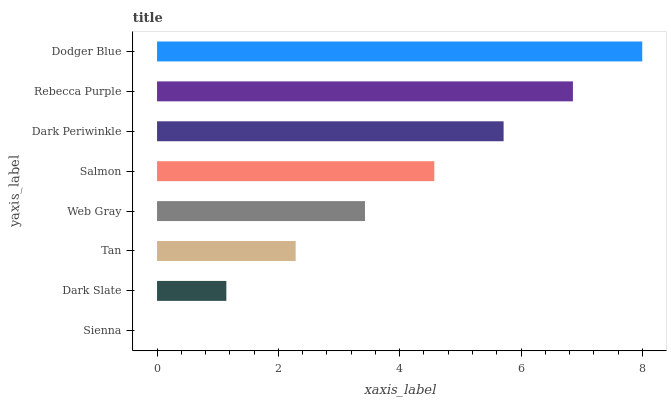Is Sienna the minimum?
Answer yes or no. Yes. Is Dodger Blue the maximum?
Answer yes or no. Yes. Is Dark Slate the minimum?
Answer yes or no. No. Is Dark Slate the maximum?
Answer yes or no. No. Is Dark Slate greater than Sienna?
Answer yes or no. Yes. Is Sienna less than Dark Slate?
Answer yes or no. Yes. Is Sienna greater than Dark Slate?
Answer yes or no. No. Is Dark Slate less than Sienna?
Answer yes or no. No. Is Salmon the high median?
Answer yes or no. Yes. Is Web Gray the low median?
Answer yes or no. Yes. Is Tan the high median?
Answer yes or no. No. Is Sienna the low median?
Answer yes or no. No. 